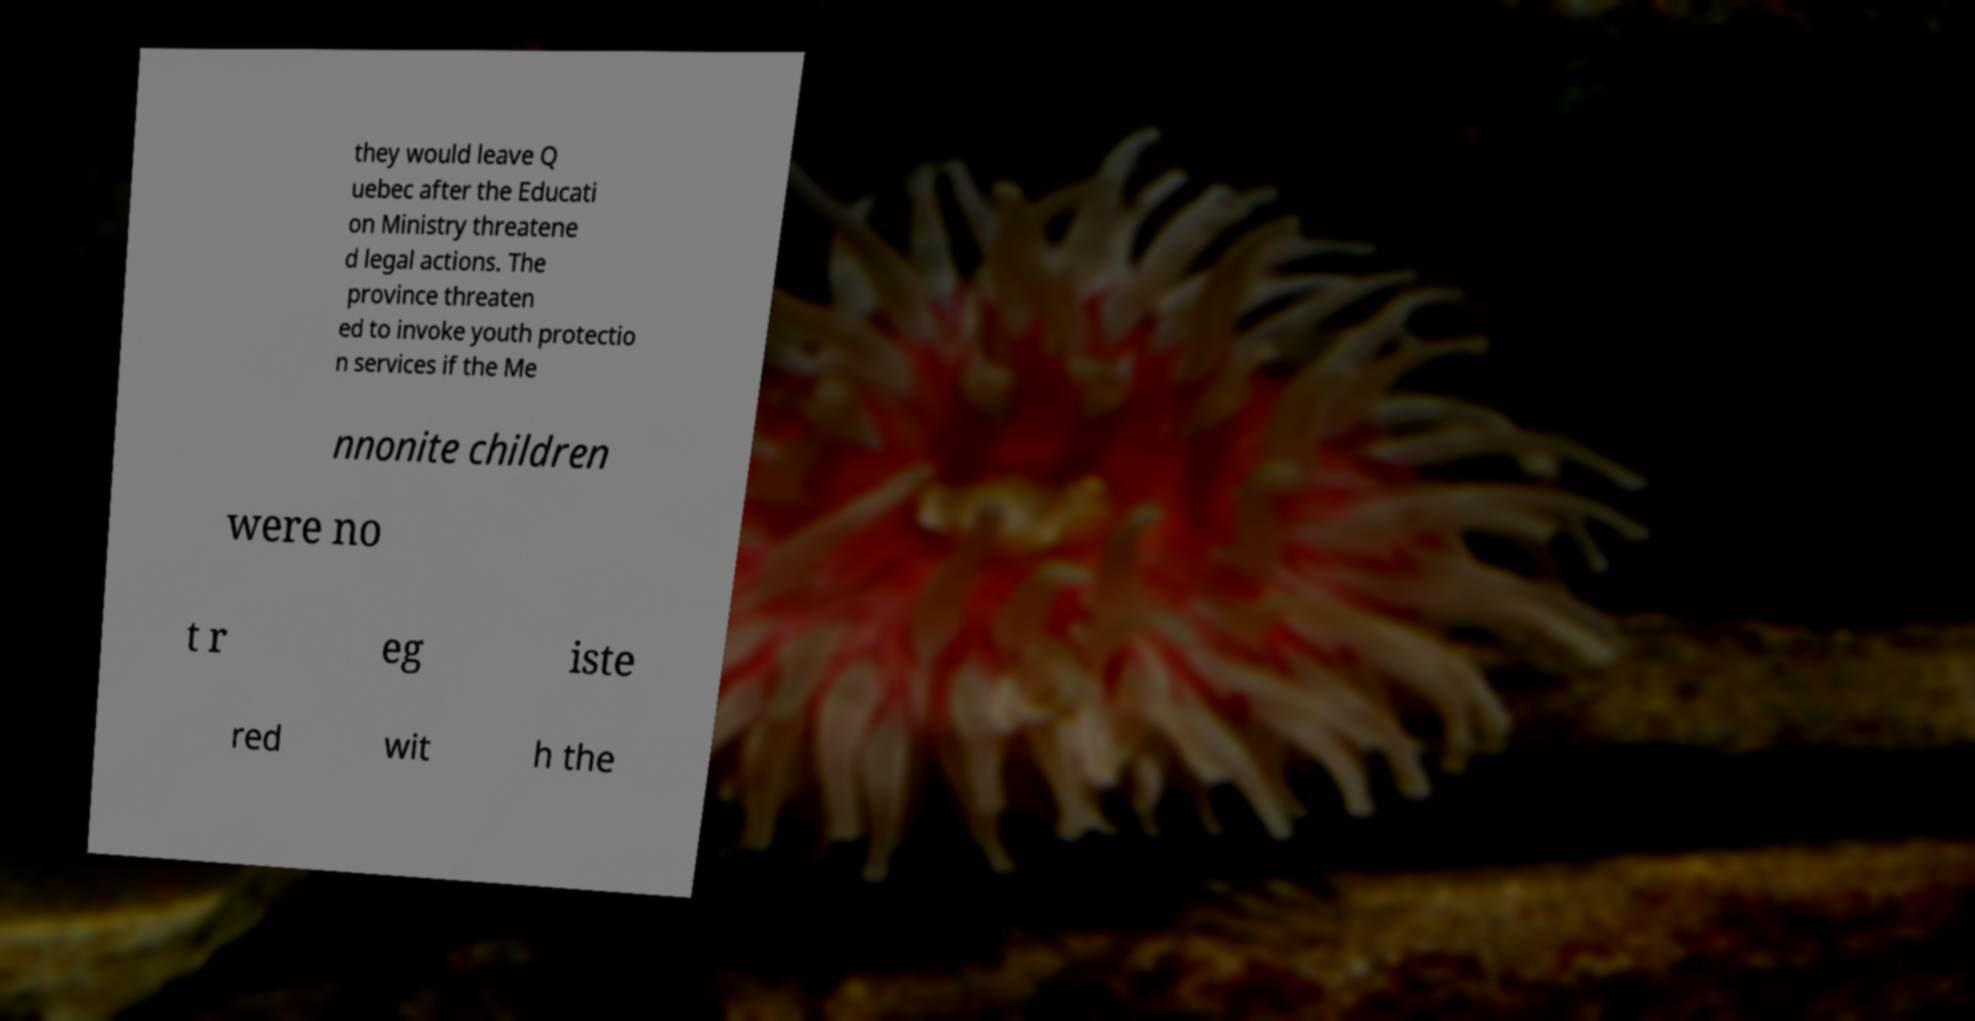There's text embedded in this image that I need extracted. Can you transcribe it verbatim? they would leave Q uebec after the Educati on Ministry threatene d legal actions. The province threaten ed to invoke youth protectio n services if the Me nnonite children were no t r eg iste red wit h the 